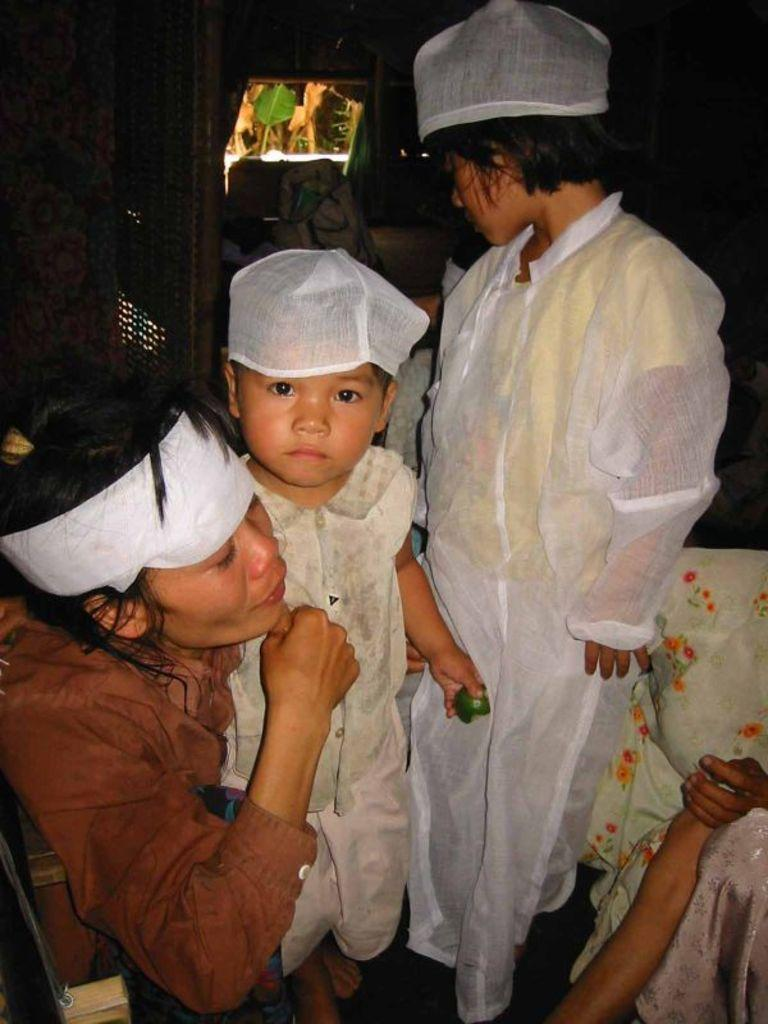How many people are in the image? There are people in the image, but the exact number is not specified. What are some of the people doing in the image? Some people are sitting, and some people are standing. Can you describe the background of the image? There are objects in the background of the image, but their specific nature is not mentioned. Where are the dinosaurs located in the image? There are no dinosaurs present in the image. 